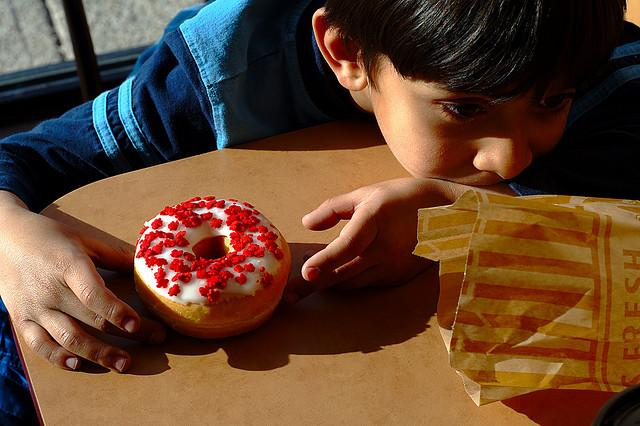When did the restaurant make this donut? Please explain your reasoning. same day. On the packaging next to the donut you can see majority of the wording fresh.  this would indicate that products sold with this package would be baked the same day. 